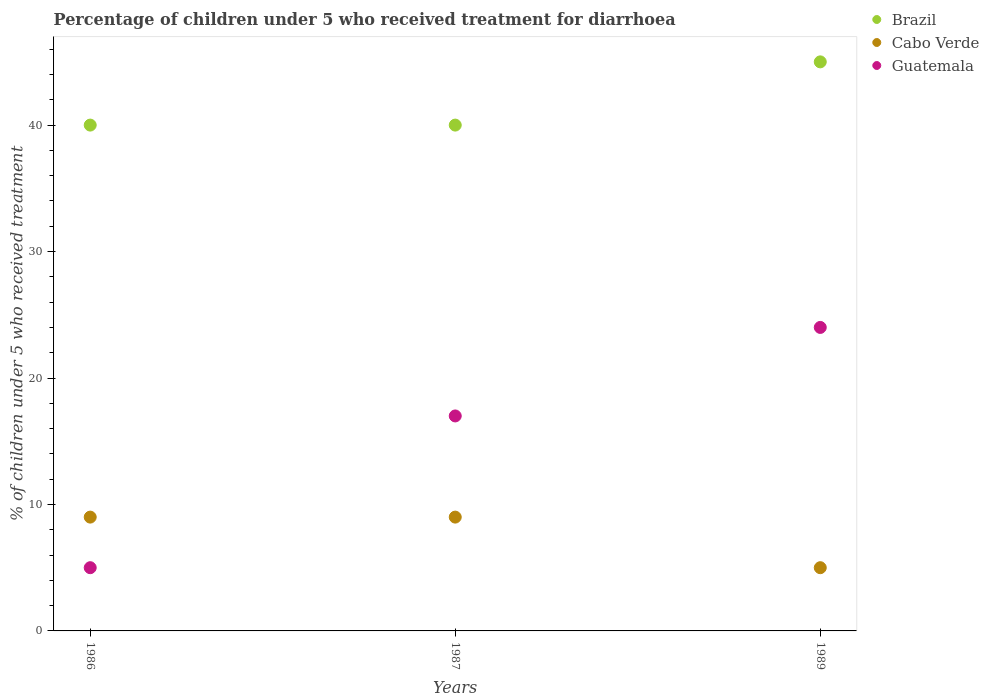How many different coloured dotlines are there?
Ensure brevity in your answer.  3. In which year was the percentage of children who received treatment for diarrhoea  in Brazil minimum?
Your response must be concise. 1986. What is the total percentage of children who received treatment for diarrhoea  in Guatemala in the graph?
Make the answer very short. 46. What is the difference between the percentage of children who received treatment for diarrhoea  in Guatemala in 1987 and that in 1989?
Your response must be concise. -7. What is the difference between the percentage of children who received treatment for diarrhoea  in Brazil in 1986 and the percentage of children who received treatment for diarrhoea  in Guatemala in 1987?
Provide a succinct answer. 23. What is the average percentage of children who received treatment for diarrhoea  in Guatemala per year?
Make the answer very short. 15.33. In the year 1987, what is the difference between the percentage of children who received treatment for diarrhoea  in Cabo Verde and percentage of children who received treatment for diarrhoea  in Guatemala?
Ensure brevity in your answer.  -8. In how many years, is the percentage of children who received treatment for diarrhoea  in Guatemala greater than 28 %?
Offer a very short reply. 0. What is the difference between the highest and the second highest percentage of children who received treatment for diarrhoea  in Brazil?
Provide a short and direct response. 5. Is the sum of the percentage of children who received treatment for diarrhoea  in Brazil in 1986 and 1989 greater than the maximum percentage of children who received treatment for diarrhoea  in Cabo Verde across all years?
Keep it short and to the point. Yes. Is the percentage of children who received treatment for diarrhoea  in Brazil strictly greater than the percentage of children who received treatment for diarrhoea  in Cabo Verde over the years?
Your answer should be very brief. Yes. Are the values on the major ticks of Y-axis written in scientific E-notation?
Make the answer very short. No. Does the graph contain grids?
Your answer should be compact. No. How many legend labels are there?
Your answer should be very brief. 3. How are the legend labels stacked?
Make the answer very short. Vertical. What is the title of the graph?
Offer a terse response. Percentage of children under 5 who received treatment for diarrhoea. What is the label or title of the Y-axis?
Your answer should be compact. % of children under 5 who received treatment. What is the % of children under 5 who received treatment in Brazil in 1986?
Provide a succinct answer. 40. What is the % of children under 5 who received treatment in Cabo Verde in 1986?
Make the answer very short. 9. What is the % of children under 5 who received treatment in Cabo Verde in 1987?
Provide a short and direct response. 9. What is the % of children under 5 who received treatment of Guatemala in 1987?
Provide a short and direct response. 17. What is the % of children under 5 who received treatment in Brazil in 1989?
Make the answer very short. 45. What is the % of children under 5 who received treatment in Cabo Verde in 1989?
Offer a very short reply. 5. What is the % of children under 5 who received treatment of Guatemala in 1989?
Make the answer very short. 24. Across all years, what is the maximum % of children under 5 who received treatment in Cabo Verde?
Your answer should be compact. 9. Across all years, what is the minimum % of children under 5 who received treatment of Brazil?
Provide a succinct answer. 40. What is the total % of children under 5 who received treatment of Brazil in the graph?
Keep it short and to the point. 125. What is the difference between the % of children under 5 who received treatment in Guatemala in 1986 and that in 1987?
Offer a very short reply. -12. What is the difference between the % of children under 5 who received treatment in Cabo Verde in 1986 and that in 1989?
Your answer should be very brief. 4. What is the difference between the % of children under 5 who received treatment in Brazil in 1987 and that in 1989?
Make the answer very short. -5. What is the difference between the % of children under 5 who received treatment in Cabo Verde in 1987 and that in 1989?
Your answer should be compact. 4. What is the difference between the % of children under 5 who received treatment in Brazil in 1986 and the % of children under 5 who received treatment in Cabo Verde in 1987?
Make the answer very short. 31. What is the difference between the % of children under 5 who received treatment in Brazil in 1986 and the % of children under 5 who received treatment in Guatemala in 1987?
Your answer should be compact. 23. What is the difference between the % of children under 5 who received treatment of Cabo Verde in 1986 and the % of children under 5 who received treatment of Guatemala in 1987?
Offer a very short reply. -8. What is the difference between the % of children under 5 who received treatment of Brazil in 1986 and the % of children under 5 who received treatment of Guatemala in 1989?
Your response must be concise. 16. What is the difference between the % of children under 5 who received treatment of Cabo Verde in 1986 and the % of children under 5 who received treatment of Guatemala in 1989?
Give a very brief answer. -15. What is the difference between the % of children under 5 who received treatment of Brazil in 1987 and the % of children under 5 who received treatment of Cabo Verde in 1989?
Your response must be concise. 35. What is the difference between the % of children under 5 who received treatment in Brazil in 1987 and the % of children under 5 who received treatment in Guatemala in 1989?
Provide a short and direct response. 16. What is the average % of children under 5 who received treatment in Brazil per year?
Offer a very short reply. 41.67. What is the average % of children under 5 who received treatment in Cabo Verde per year?
Your response must be concise. 7.67. What is the average % of children under 5 who received treatment in Guatemala per year?
Offer a very short reply. 15.33. In the year 1986, what is the difference between the % of children under 5 who received treatment in Brazil and % of children under 5 who received treatment in Guatemala?
Make the answer very short. 35. In the year 1986, what is the difference between the % of children under 5 who received treatment in Cabo Verde and % of children under 5 who received treatment in Guatemala?
Your answer should be compact. 4. In the year 1987, what is the difference between the % of children under 5 who received treatment in Brazil and % of children under 5 who received treatment in Guatemala?
Provide a succinct answer. 23. In the year 1987, what is the difference between the % of children under 5 who received treatment in Cabo Verde and % of children under 5 who received treatment in Guatemala?
Offer a very short reply. -8. In the year 1989, what is the difference between the % of children under 5 who received treatment in Cabo Verde and % of children under 5 who received treatment in Guatemala?
Provide a succinct answer. -19. What is the ratio of the % of children under 5 who received treatment in Guatemala in 1986 to that in 1987?
Make the answer very short. 0.29. What is the ratio of the % of children under 5 who received treatment in Guatemala in 1986 to that in 1989?
Provide a succinct answer. 0.21. What is the ratio of the % of children under 5 who received treatment in Guatemala in 1987 to that in 1989?
Provide a short and direct response. 0.71. What is the difference between the highest and the second highest % of children under 5 who received treatment of Brazil?
Make the answer very short. 5. What is the difference between the highest and the second highest % of children under 5 who received treatment in Cabo Verde?
Provide a short and direct response. 0. What is the difference between the highest and the second highest % of children under 5 who received treatment of Guatemala?
Ensure brevity in your answer.  7. 